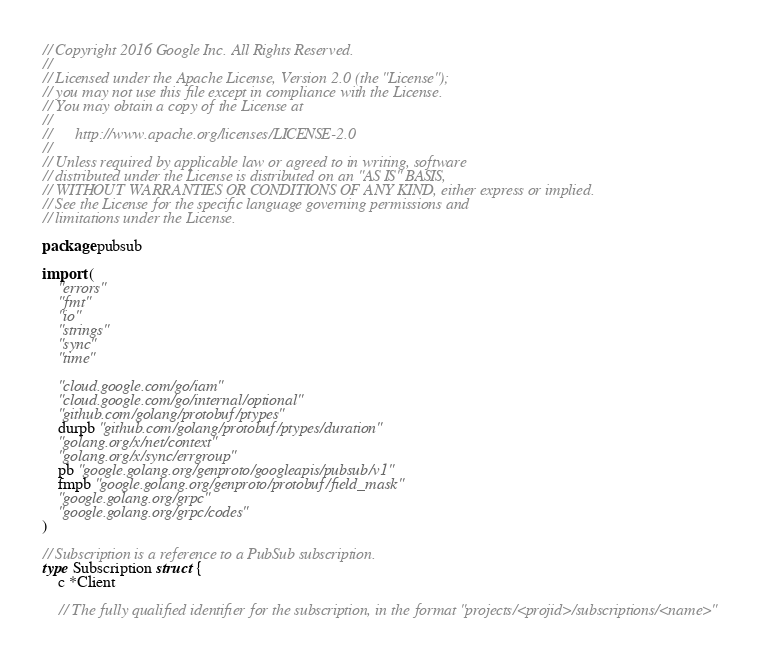Convert code to text. <code><loc_0><loc_0><loc_500><loc_500><_Go_>// Copyright 2016 Google Inc. All Rights Reserved.
//
// Licensed under the Apache License, Version 2.0 (the "License");
// you may not use this file except in compliance with the License.
// You may obtain a copy of the License at
//
//      http://www.apache.org/licenses/LICENSE-2.0
//
// Unless required by applicable law or agreed to in writing, software
// distributed under the License is distributed on an "AS IS" BASIS,
// WITHOUT WARRANTIES OR CONDITIONS OF ANY KIND, either express or implied.
// See the License for the specific language governing permissions and
// limitations under the License.

package pubsub

import (
	"errors"
	"fmt"
	"io"
	"strings"
	"sync"
	"time"

	"cloud.google.com/go/iam"
	"cloud.google.com/go/internal/optional"
	"github.com/golang/protobuf/ptypes"
	durpb "github.com/golang/protobuf/ptypes/duration"
	"golang.org/x/net/context"
	"golang.org/x/sync/errgroup"
	pb "google.golang.org/genproto/googleapis/pubsub/v1"
	fmpb "google.golang.org/genproto/protobuf/field_mask"
	"google.golang.org/grpc"
	"google.golang.org/grpc/codes"
)

// Subscription is a reference to a PubSub subscription.
type Subscription struct {
	c *Client

	// The fully qualified identifier for the subscription, in the format "projects/<projid>/subscriptions/<name>"</code> 